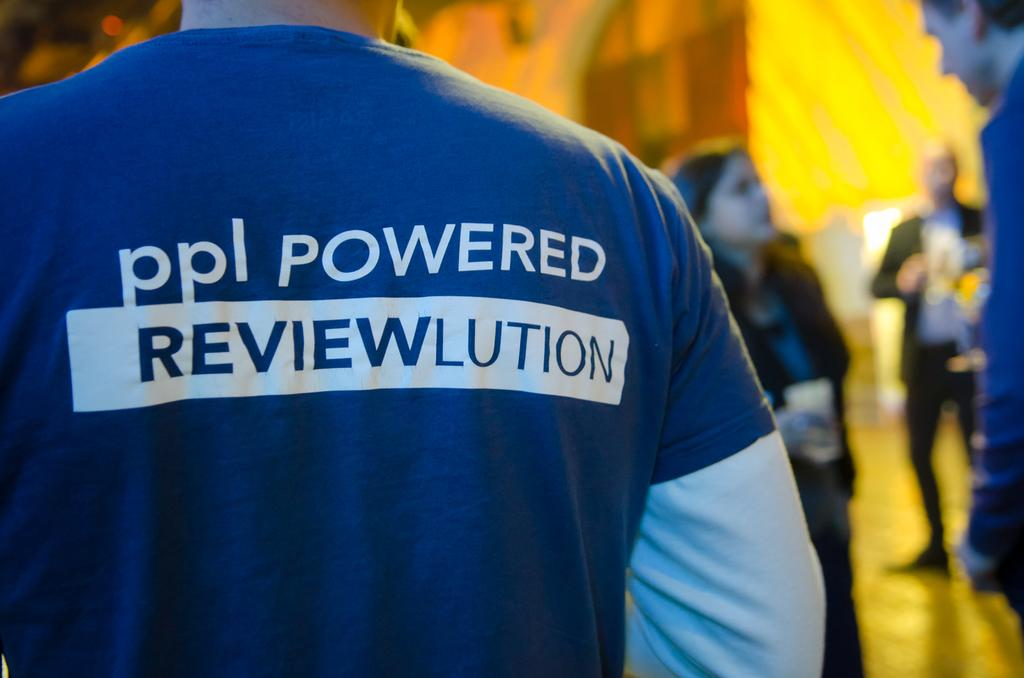<image>
Summarize the visual content of the image. A blue shirt is shown with the words ppl POWERED on the back. 